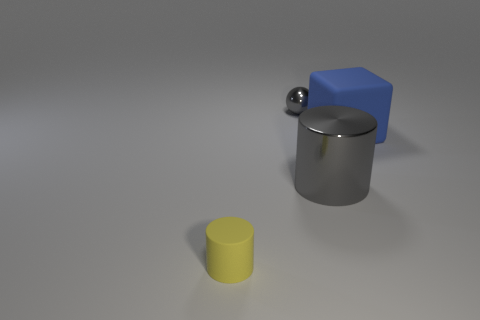Add 4 matte cylinders. How many objects exist? 8 Subtract all blocks. How many objects are left? 3 Add 3 small balls. How many small balls are left? 4 Add 3 rubber cylinders. How many rubber cylinders exist? 4 Subtract 1 gray spheres. How many objects are left? 3 Subtract all small things. Subtract all yellow objects. How many objects are left? 1 